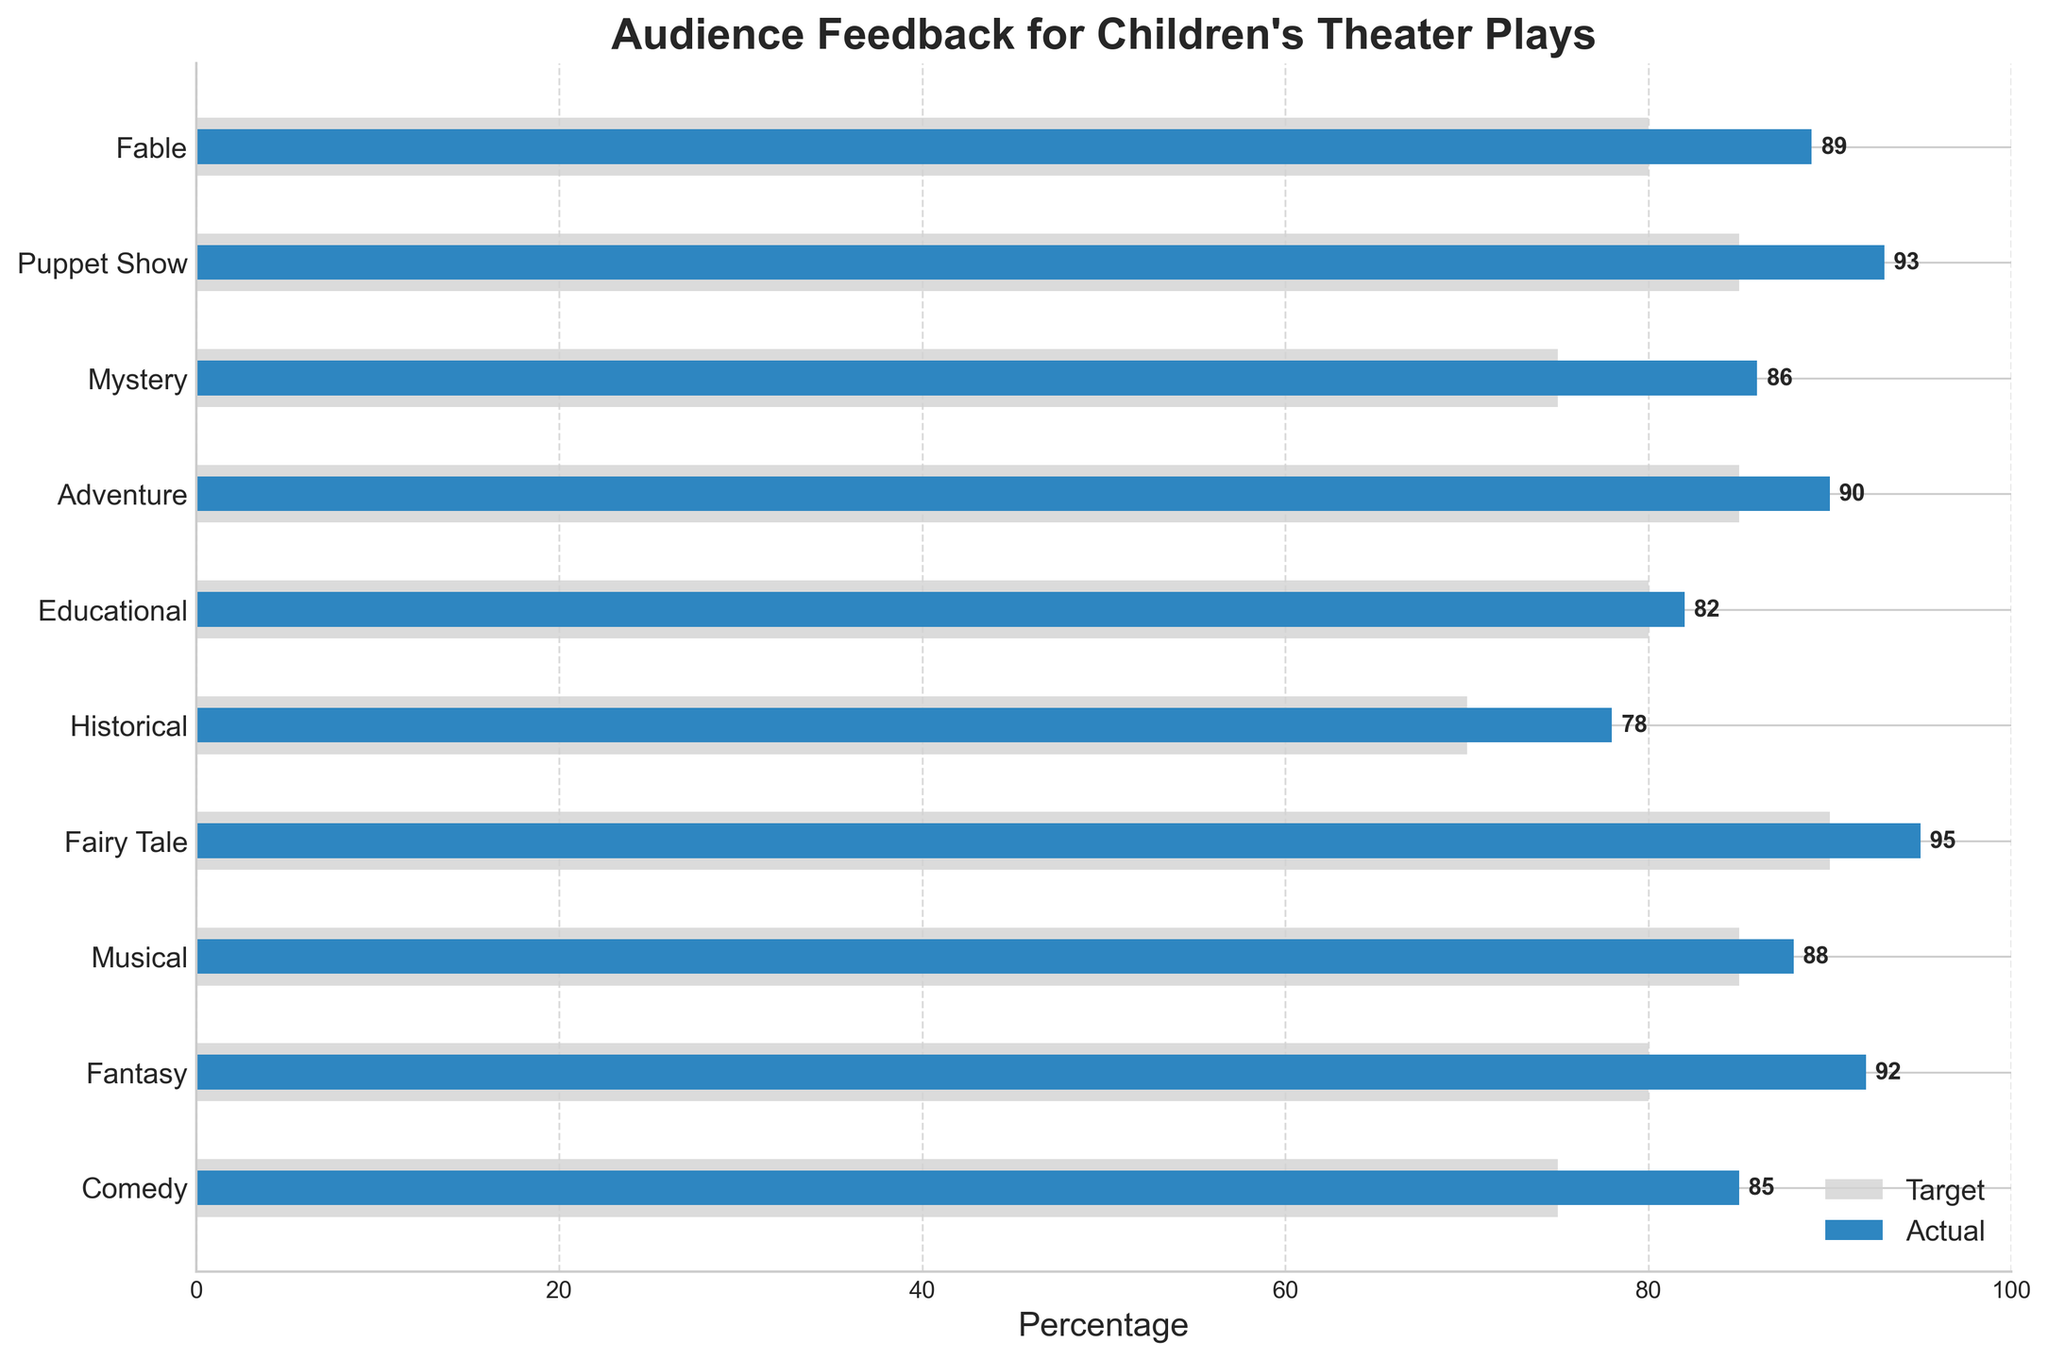Which play genre received the highest percentage of positive audience feedback? In the figure, "Fairy Tale" has the highest actual percentage bar, which is labeled as 95%
Answer: Fairy Tale What is the title of the figure? The title of the figure is located at the top, stating "Audience Feedback for Children's Theater Plays"
Answer: Audience Feedback for Children's Theater Plays How many play genres exceeded their target audience feedback? By comparing the height of the "Actual" bars with the "Target" bars, we see that Comedy, Fantasy, Musical, Fairy Tale, Historical, Educational, Adventure, Mystery, Puppet Show, and Fable all exceed their target percentages. That's 10 genres.
Answer: 10 What’s the difference between the actual and target audience feedback for a Comedy play? The actual feedback for Comedy is 85%, and the target is 75%. The difference is calculated by 85% - 75%
Answer: 10% Which genre’s actual audience feedback is equal to its target feedback? By observing the bars, Educational is the genre where the actual feedback is equal to the target feedback, both being 82%
Answer: Educational What is the average actual audience feedback percentage across all genres? Sum of all actual feedback percentages: 85+92+88+95+78+82+90+86+93+89 = 878. Number of genres: 10. Average = 878 / 10
Answer: 87.8% Which genre has the largest discrepancy between actual and target audience feedback? By calculating the discrepancies for each genre, Fairy Tale has the highest difference, with a discrepancy of 95% (actual) - 90% (target) = 5%
Answer: Fairy Tale What’s the most common target audience feedback percentage range represented in the figure? Most target feedback percentages have values around 80-90%. Counting the occurrences in this range: Fantasy, Musical, Fairy Tale, Educational, Adventure, Puppet Show, and Fable, making 7 out of 10.
Answer: 80-90% Among the genres, which received the lowest actual audience feedback percentage? The "Historical" genre has the lowest actual audience feedback percentage with 78%
Answer: Historical 